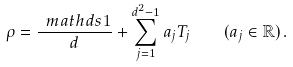<formula> <loc_0><loc_0><loc_500><loc_500>\rho = \frac { \ m a t h d s { 1 } } { d } + \sum _ { j = 1 } ^ { d ^ { 2 } - 1 } a _ { j } T _ { j } \quad ( a _ { j } \in \mathbb { R } ) \, .</formula> 